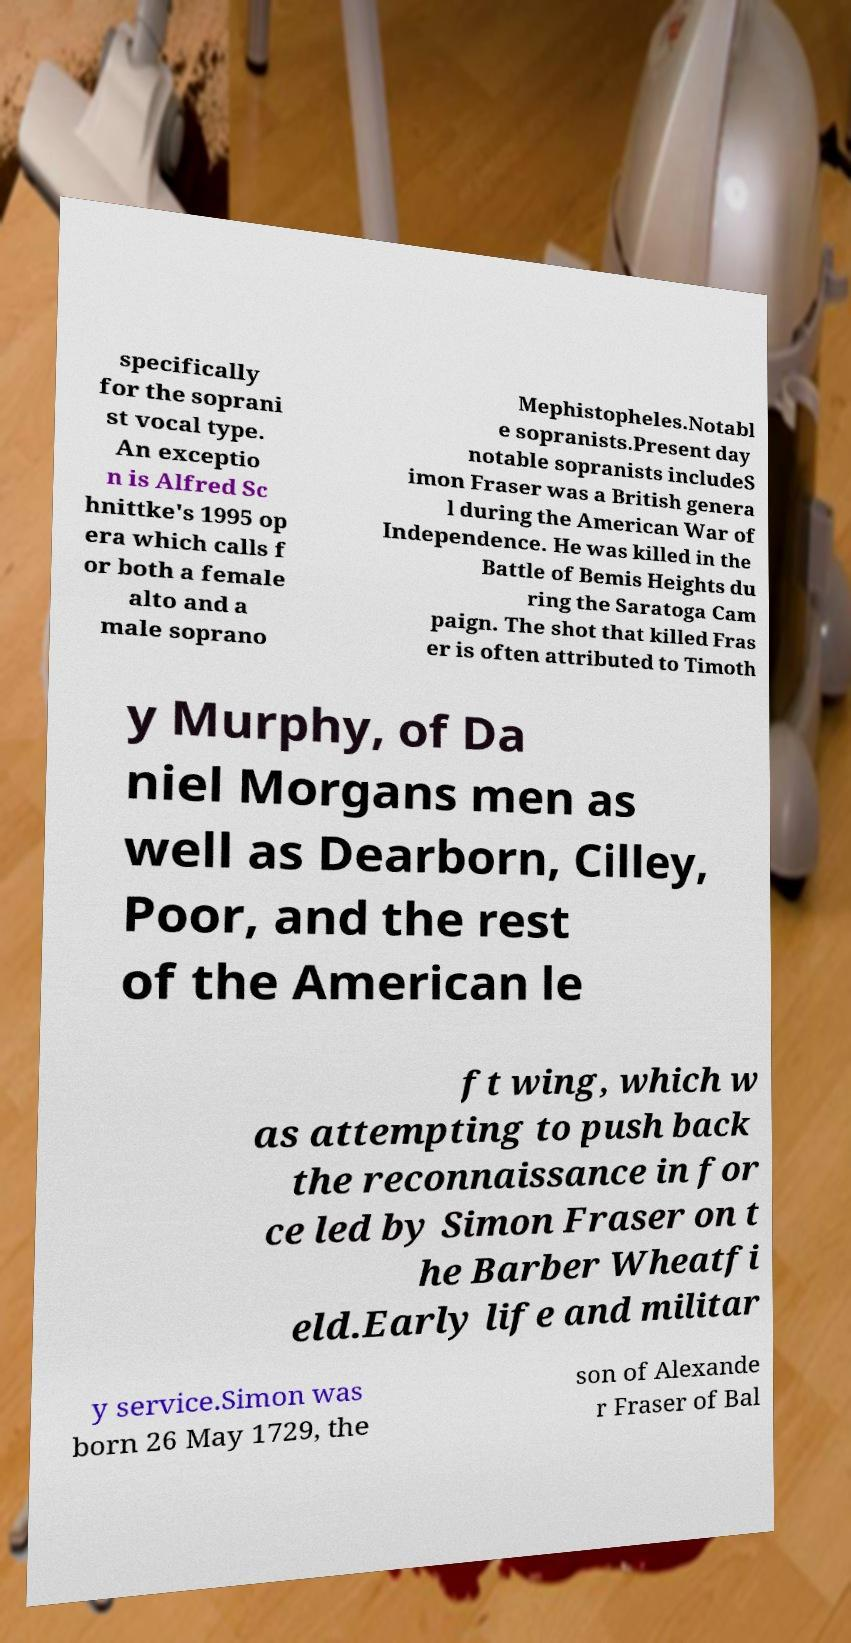I need the written content from this picture converted into text. Can you do that? specifically for the soprani st vocal type. An exceptio n is Alfred Sc hnittke's 1995 op era which calls f or both a female alto and a male soprano Mephistopheles.Notabl e sopranists.Present day notable sopranists includeS imon Fraser was a British genera l during the American War of Independence. He was killed in the Battle of Bemis Heights du ring the Saratoga Cam paign. The shot that killed Fras er is often attributed to Timoth y Murphy, of Da niel Morgans men as well as Dearborn, Cilley, Poor, and the rest of the American le ft wing, which w as attempting to push back the reconnaissance in for ce led by Simon Fraser on t he Barber Wheatfi eld.Early life and militar y service.Simon was born 26 May 1729, the son of Alexande r Fraser of Bal 